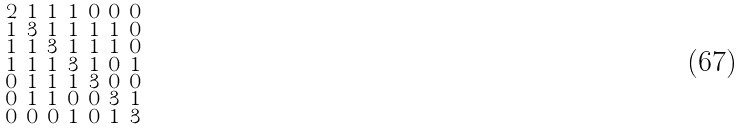<formula> <loc_0><loc_0><loc_500><loc_500>\begin{smallmatrix} 2 & 1 & 1 & 1 & 0 & 0 & 0 \\ 1 & 3 & 1 & 1 & 1 & 1 & 0 \\ 1 & 1 & 3 & 1 & 1 & 1 & 0 \\ 1 & 1 & 1 & 3 & 1 & 0 & 1 \\ 0 & 1 & 1 & 1 & 3 & 0 & 0 \\ 0 & 1 & 1 & 0 & 0 & 3 & 1 \\ 0 & 0 & 0 & 1 & 0 & 1 & 3 \end{smallmatrix}</formula> 